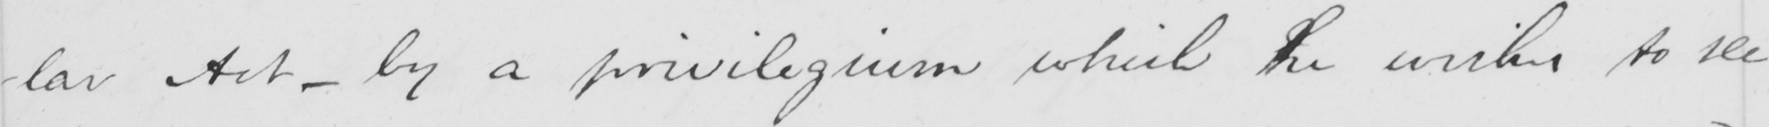Can you tell me what this handwritten text says? -lar Act  _  by a priviligium which he wishes to see 